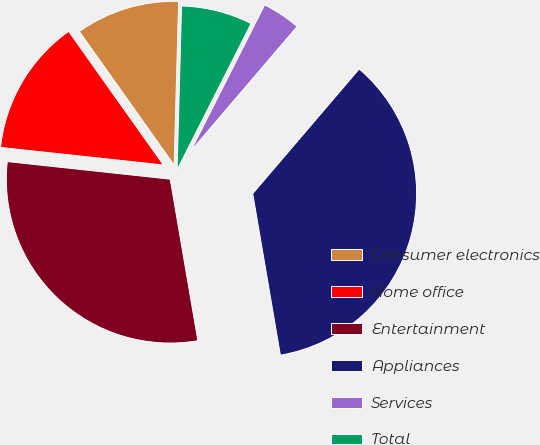Convert chart to OTSL. <chart><loc_0><loc_0><loc_500><loc_500><pie_chart><fcel>Consumer electronics<fcel>Home office<fcel>Entertainment<fcel>Appliances<fcel>Services<fcel>Total<nl><fcel>10.25%<fcel>13.47%<fcel>29.41%<fcel>36.05%<fcel>3.8%<fcel>7.02%<nl></chart> 